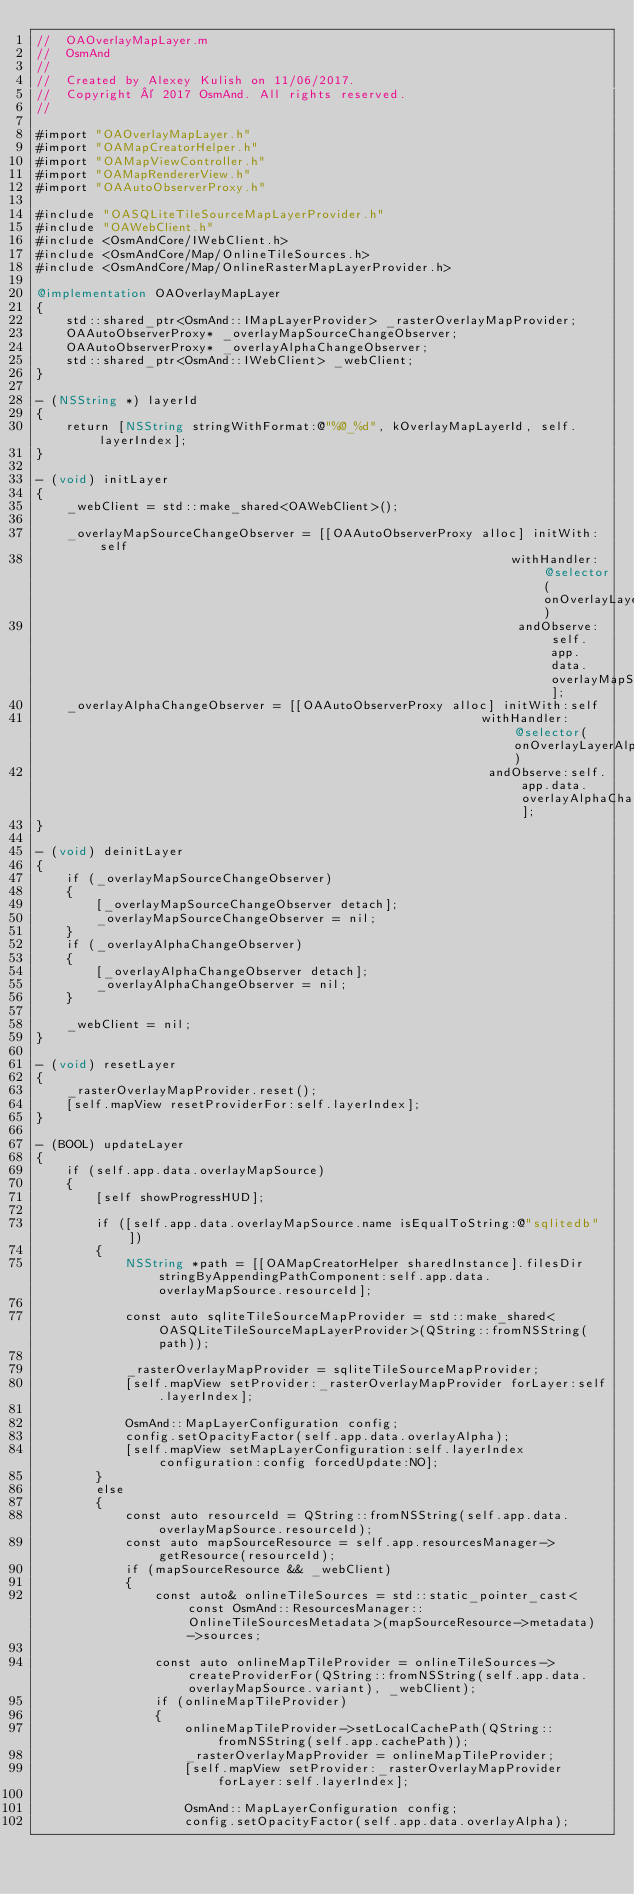<code> <loc_0><loc_0><loc_500><loc_500><_ObjectiveC_>//  OAOverlayMapLayer.m
//  OsmAnd
//
//  Created by Alexey Kulish on 11/06/2017.
//  Copyright © 2017 OsmAnd. All rights reserved.
//

#import "OAOverlayMapLayer.h"
#import "OAMapCreatorHelper.h"
#import "OAMapViewController.h"
#import "OAMapRendererView.h"
#import "OAAutoObserverProxy.h"

#include "OASQLiteTileSourceMapLayerProvider.h"
#include "OAWebClient.h"
#include <OsmAndCore/IWebClient.h>
#include <OsmAndCore/Map/OnlineTileSources.h>
#include <OsmAndCore/Map/OnlineRasterMapLayerProvider.h>

@implementation OAOverlayMapLayer
{
    std::shared_ptr<OsmAnd::IMapLayerProvider> _rasterOverlayMapProvider;
    OAAutoObserverProxy* _overlayMapSourceChangeObserver;
    OAAutoObserverProxy* _overlayAlphaChangeObserver;
    std::shared_ptr<OsmAnd::IWebClient> _webClient;
}

- (NSString *) layerId
{
    return [NSString stringWithFormat:@"%@_%d", kOverlayMapLayerId, self.layerIndex];
}

- (void) initLayer
{
    _webClient = std::make_shared<OAWebClient>();

    _overlayMapSourceChangeObserver = [[OAAutoObserverProxy alloc] initWith:self
                                                                withHandler:@selector(onOverlayLayerChanged)
                                                                 andObserve:self.app.data.overlayMapSourceChangeObservable];
    _overlayAlphaChangeObserver = [[OAAutoObserverProxy alloc] initWith:self
                                                            withHandler:@selector(onOverlayLayerAlphaChanged)
                                                             andObserve:self.app.data.overlayAlphaChangeObservable];
}

- (void) deinitLayer
{
    if (_overlayMapSourceChangeObserver)
    {
        [_overlayMapSourceChangeObserver detach];
        _overlayMapSourceChangeObserver = nil;
    }
    if (_overlayAlphaChangeObserver)
    {
        [_overlayAlphaChangeObserver detach];
        _overlayAlphaChangeObserver = nil;
    }
    
    _webClient = nil;
}

- (void) resetLayer
{
    _rasterOverlayMapProvider.reset();
    [self.mapView resetProviderFor:self.layerIndex];
}

- (BOOL) updateLayer
{
    if (self.app.data.overlayMapSource)
    {
        [self showProgressHUD];
        
        if ([self.app.data.overlayMapSource.name isEqualToString:@"sqlitedb"])
        {
            NSString *path = [[OAMapCreatorHelper sharedInstance].filesDir stringByAppendingPathComponent:self.app.data.overlayMapSource.resourceId];
            
            const auto sqliteTileSourceMapProvider = std::make_shared<OASQLiteTileSourceMapLayerProvider>(QString::fromNSString(path));
            
            _rasterOverlayMapProvider = sqliteTileSourceMapProvider;
            [self.mapView setProvider:_rasterOverlayMapProvider forLayer:self.layerIndex];
            
            OsmAnd::MapLayerConfiguration config;
            config.setOpacityFactor(self.app.data.overlayAlpha);
            [self.mapView setMapLayerConfiguration:self.layerIndex configuration:config forcedUpdate:NO];
        }
        else
        {
            const auto resourceId = QString::fromNSString(self.app.data.overlayMapSource.resourceId);
            const auto mapSourceResource = self.app.resourcesManager->getResource(resourceId);
            if (mapSourceResource && _webClient)
            {
                const auto& onlineTileSources = std::static_pointer_cast<const OsmAnd::ResourcesManager::OnlineTileSourcesMetadata>(mapSourceResource->metadata)->sources;
                
                const auto onlineMapTileProvider = onlineTileSources->createProviderFor(QString::fromNSString(self.app.data.overlayMapSource.variant), _webClient);
                if (onlineMapTileProvider)
                {
                    onlineMapTileProvider->setLocalCachePath(QString::fromNSString(self.app.cachePath));
                    _rasterOverlayMapProvider = onlineMapTileProvider;
                    [self.mapView setProvider:_rasterOverlayMapProvider forLayer:self.layerIndex];
                    
                    OsmAnd::MapLayerConfiguration config;
                    config.setOpacityFactor(self.app.data.overlayAlpha);</code> 